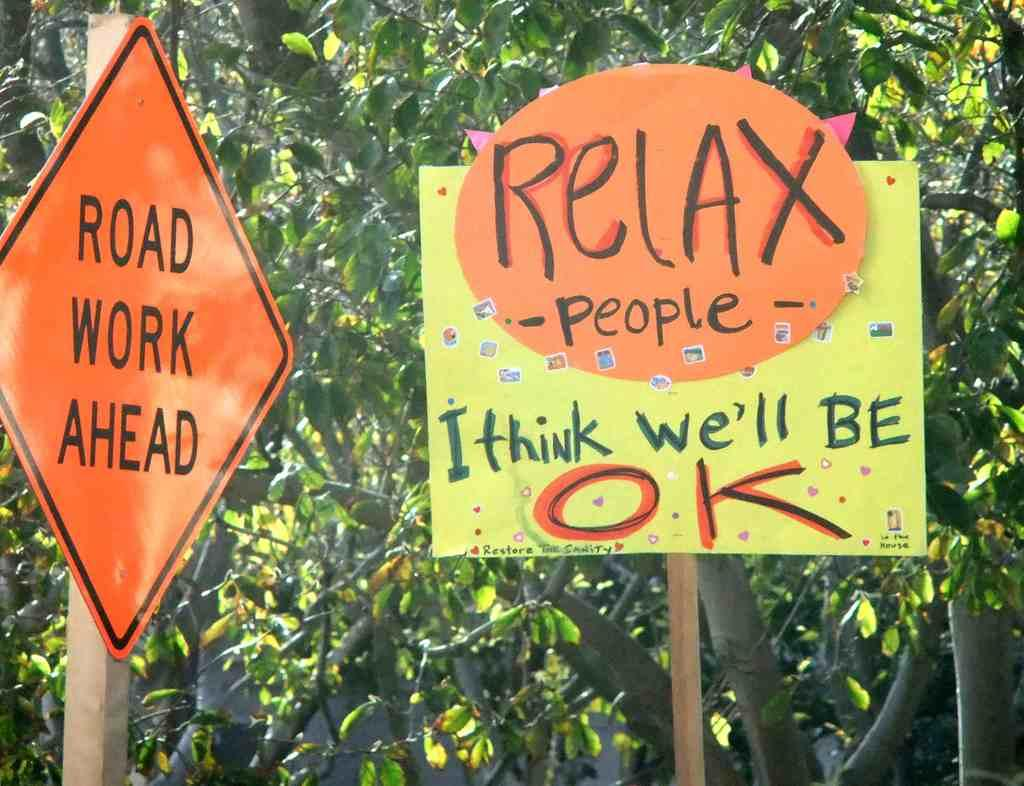What objects are present in the image that are attached to wooden sticks? There are two boards in the image that are attached to wooden sticks. What colors are the boards? The boards are in orange and yellow colors. What can be seen in the background of the image? There are trees in the background of the image. What color are the trees? The trees are green in color. What type of liquid is being used to create a relation between the boards and the wooden sticks? There is no liquid present in the image, and the boards are attached to the wooden sticks through some other means. Can you see any jellyfish in the image? There are no jellyfish present in the image. 